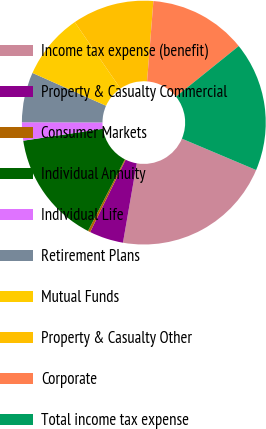Convert chart to OTSL. <chart><loc_0><loc_0><loc_500><loc_500><pie_chart><fcel>Income tax expense (benefit)<fcel>Property & Casualty Commercial<fcel>Consumer Markets<fcel>Individual Annuity<fcel>Individual Life<fcel>Retirement Plans<fcel>Mutual Funds<fcel>Property & Casualty Other<fcel>Corporate<fcel>Total income tax expense<nl><fcel>21.38%<fcel>4.52%<fcel>0.31%<fcel>15.06%<fcel>2.42%<fcel>6.63%<fcel>8.74%<fcel>10.84%<fcel>12.95%<fcel>17.16%<nl></chart> 